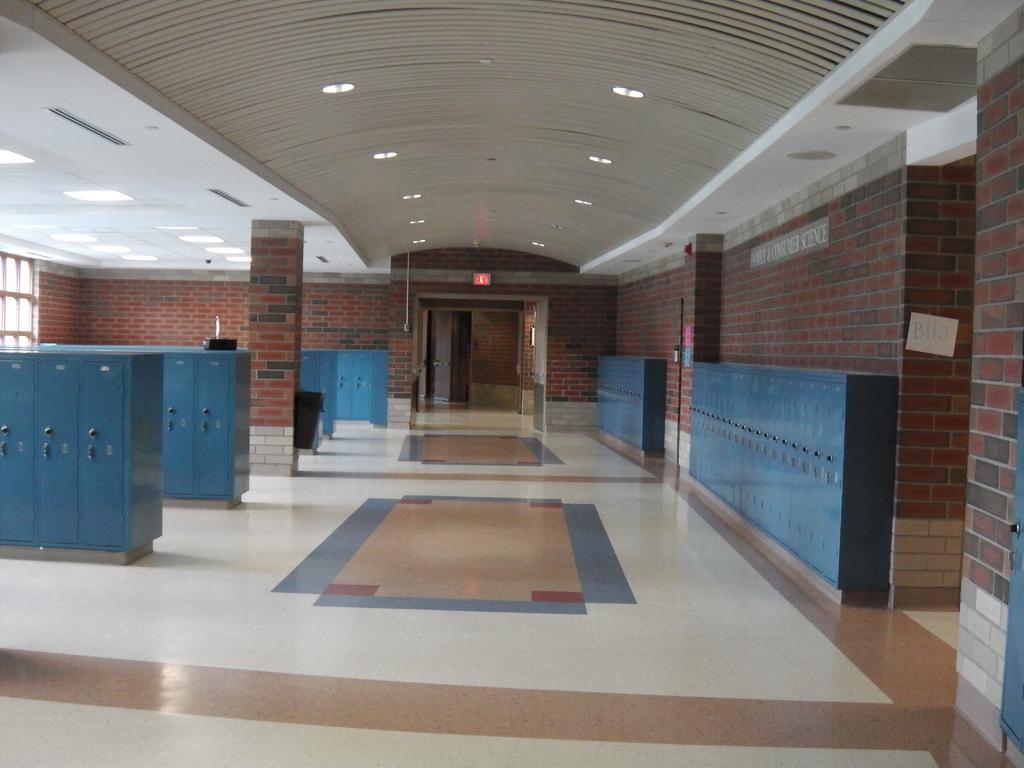How would you summarize this image in a sentence or two? This picture is taken inside a room. There are few wardrobes on the floor. Right side few cupboards are attached to the wall. Background there is a wall having windows and door. Top of the image there are few lights attached to the roof. 